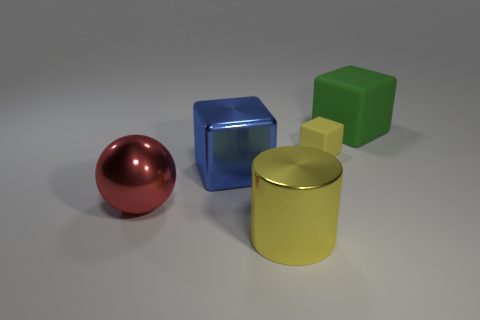Do the big thing on the right side of the small yellow cube and the metal thing that is on the left side of the big blue metal object have the same color?
Offer a terse response. No. There is another rubber cube that is the same size as the blue cube; what color is it?
Give a very brief answer. Green. Is there a small rubber thing that has the same color as the sphere?
Make the answer very short. No. There is a metal thing that is behind the red ball; is its size the same as the small matte thing?
Offer a terse response. No. Is the number of rubber things left of the small block the same as the number of big yellow shiny objects?
Keep it short and to the point. No. What number of things are matte blocks right of the tiny yellow thing or yellow rubber things?
Ensure brevity in your answer.  2. What is the shape of the thing that is in front of the large blue block and behind the large shiny cylinder?
Provide a short and direct response. Sphere. How many things are big cubes behind the small yellow cube or blocks behind the large yellow cylinder?
Your response must be concise. 3. What number of other objects are there of the same size as the shiny cylinder?
Offer a very short reply. 3. There is a big block behind the big blue cube; is it the same color as the sphere?
Your answer should be compact. No. 